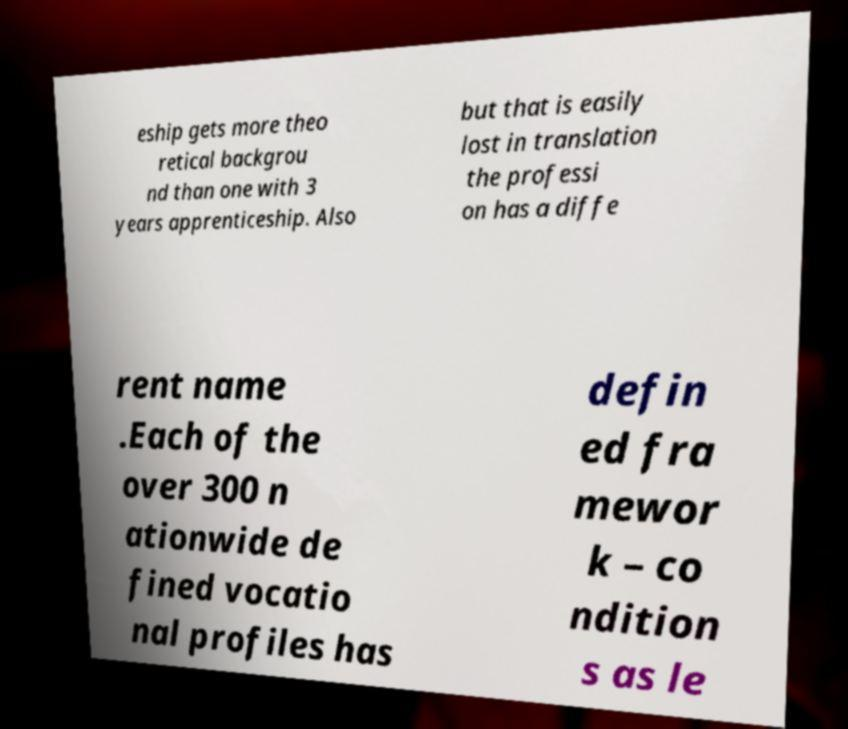For documentation purposes, I need the text within this image transcribed. Could you provide that? eship gets more theo retical backgrou nd than one with 3 years apprenticeship. Also but that is easily lost in translation the professi on has a diffe rent name .Each of the over 300 n ationwide de fined vocatio nal profiles has defin ed fra mewor k – co ndition s as le 